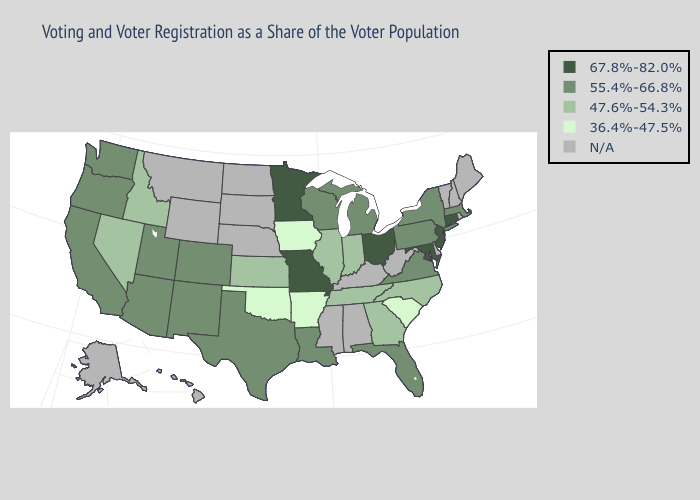Name the states that have a value in the range N/A?
Quick response, please. Alabama, Alaska, Delaware, Hawaii, Kentucky, Maine, Mississippi, Montana, Nebraska, New Hampshire, North Dakota, Rhode Island, South Dakota, Vermont, West Virginia, Wyoming. Name the states that have a value in the range N/A?
Concise answer only. Alabama, Alaska, Delaware, Hawaii, Kentucky, Maine, Mississippi, Montana, Nebraska, New Hampshire, North Dakota, Rhode Island, South Dakota, Vermont, West Virginia, Wyoming. What is the lowest value in the Northeast?
Be succinct. 55.4%-66.8%. Among the states that border Arizona , which have the lowest value?
Keep it brief. Nevada. Does Missouri have the highest value in the MidWest?
Be succinct. Yes. What is the value of Oklahoma?
Answer briefly. 36.4%-47.5%. Name the states that have a value in the range N/A?
Keep it brief. Alabama, Alaska, Delaware, Hawaii, Kentucky, Maine, Mississippi, Montana, Nebraska, New Hampshire, North Dakota, Rhode Island, South Dakota, Vermont, West Virginia, Wyoming. What is the value of Iowa?
Be succinct. 36.4%-47.5%. What is the highest value in the Northeast ?
Answer briefly. 67.8%-82.0%. Among the states that border Rhode Island , does Connecticut have the highest value?
Short answer required. Yes. Name the states that have a value in the range 67.8%-82.0%?
Quick response, please. Connecticut, Maryland, Minnesota, Missouri, New Jersey, Ohio. Does Iowa have the lowest value in the MidWest?
Give a very brief answer. Yes. Name the states that have a value in the range 47.6%-54.3%?
Be succinct. Georgia, Idaho, Illinois, Indiana, Kansas, Nevada, North Carolina, Tennessee. Which states have the lowest value in the South?
Keep it brief. Arkansas, Oklahoma, South Carolina. Name the states that have a value in the range 67.8%-82.0%?
Be succinct. Connecticut, Maryland, Minnesota, Missouri, New Jersey, Ohio. 